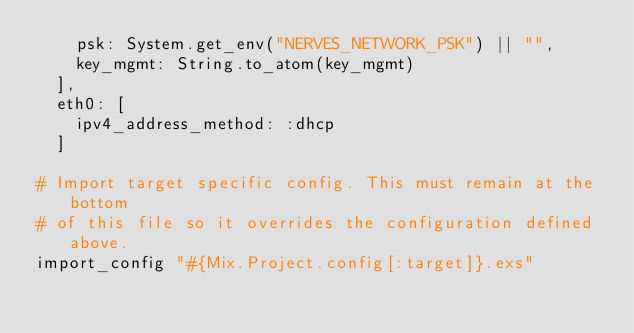<code> <loc_0><loc_0><loc_500><loc_500><_Elixir_>    psk: System.get_env("NERVES_NETWORK_PSK") || "",
    key_mgmt: String.to_atom(key_mgmt)
  ],
  eth0: [
    ipv4_address_method: :dhcp
  ]

# Import target specific config. This must remain at the bottom
# of this file so it overrides the configuration defined above.
import_config "#{Mix.Project.config[:target]}.exs"
</code> 